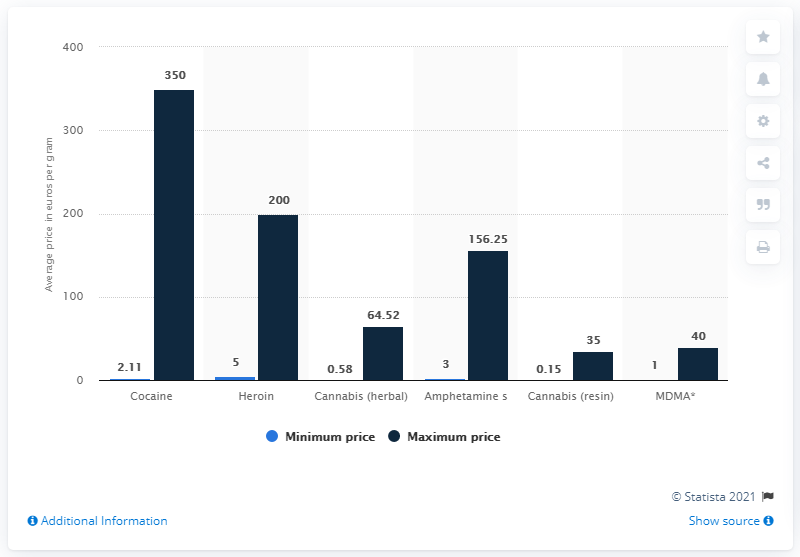What drug had the highest average price per gram among illicit drugs in Sweden in 2017? In Sweden in 2017, cocaine had the highest average price per gram amongst illicit drugs, reaching an average of 350 Swedish Krona, significantly higher than other substances according to the data. 